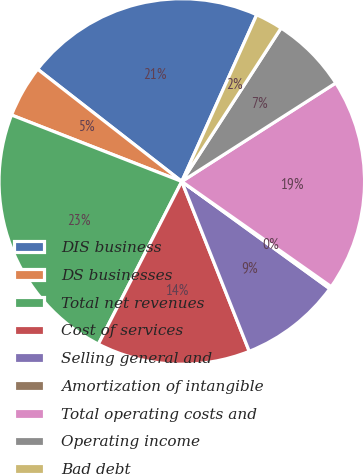Convert chart to OTSL. <chart><loc_0><loc_0><loc_500><loc_500><pie_chart><fcel>DIS business<fcel>DS businesses<fcel>Total net revenues<fcel>Cost of services<fcel>Selling general and<fcel>Amortization of intangible<fcel>Total operating costs and<fcel>Operating income<fcel>Bad debt<nl><fcel>21.19%<fcel>4.61%<fcel>23.38%<fcel>13.56%<fcel>9.0%<fcel>0.22%<fcel>18.82%<fcel>6.8%<fcel>2.42%<nl></chart> 